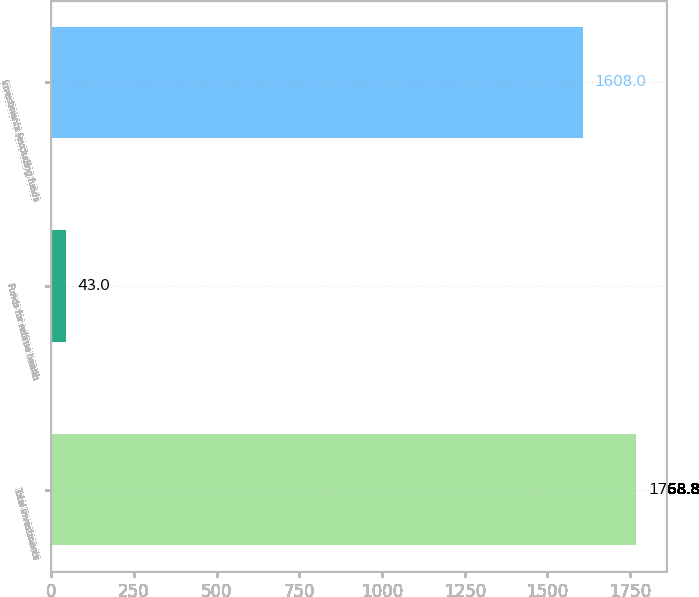<chart> <loc_0><loc_0><loc_500><loc_500><bar_chart><fcel>Total investments<fcel>Funds for retiree health<fcel>Investments (excluding funds<nl><fcel>1768.8<fcel>43<fcel>1608<nl></chart> 